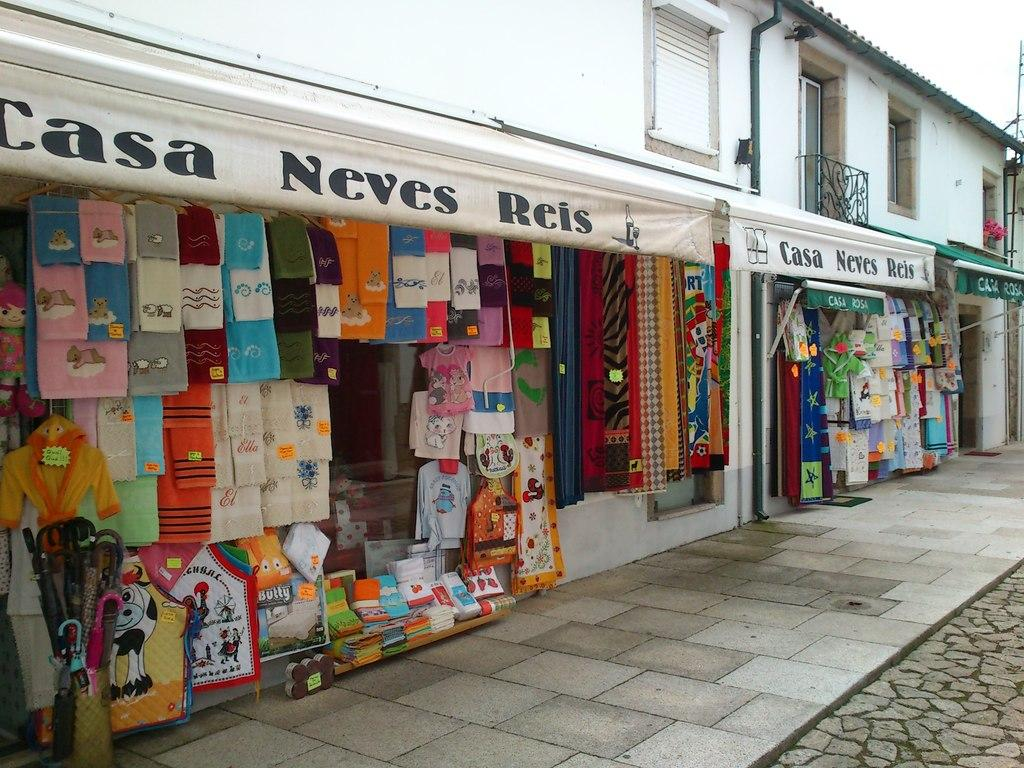<image>
Summarize the visual content of the image. Items are displayed in the Casa Neves Reis, primarily towels. 